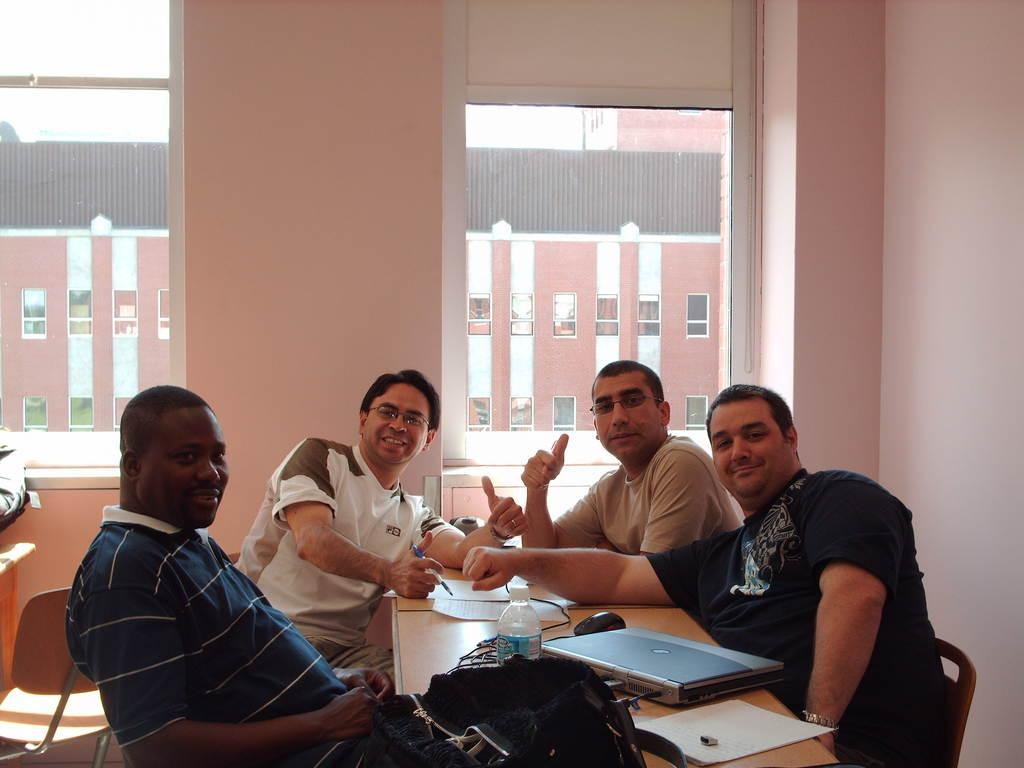How many people are in the image? There are four men in the image. What are the men doing in the image? The men are sitting on chairs. What is on the table in the image? There is a laptop and a bottle on the table. What can be seen in the background of the image? There are two windows visible in the background. What type of prose is being written on the laptop in the image? There is no indication in the image that anyone is writing prose on the laptop. How does the steam escape from the bottle in the image? There is no bottle with steam present in the image. 